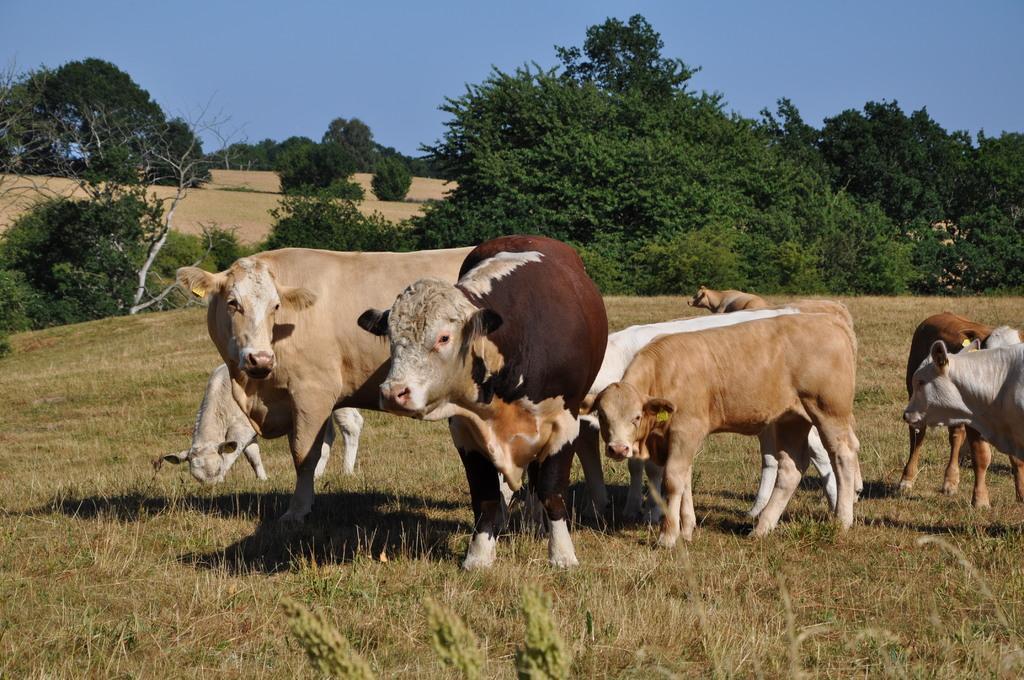Describe this image in one or two sentences. In this image I can see grass ground and on it I can see few shadows and number of cows are standing. In the background I can see number of trees and the sky. 